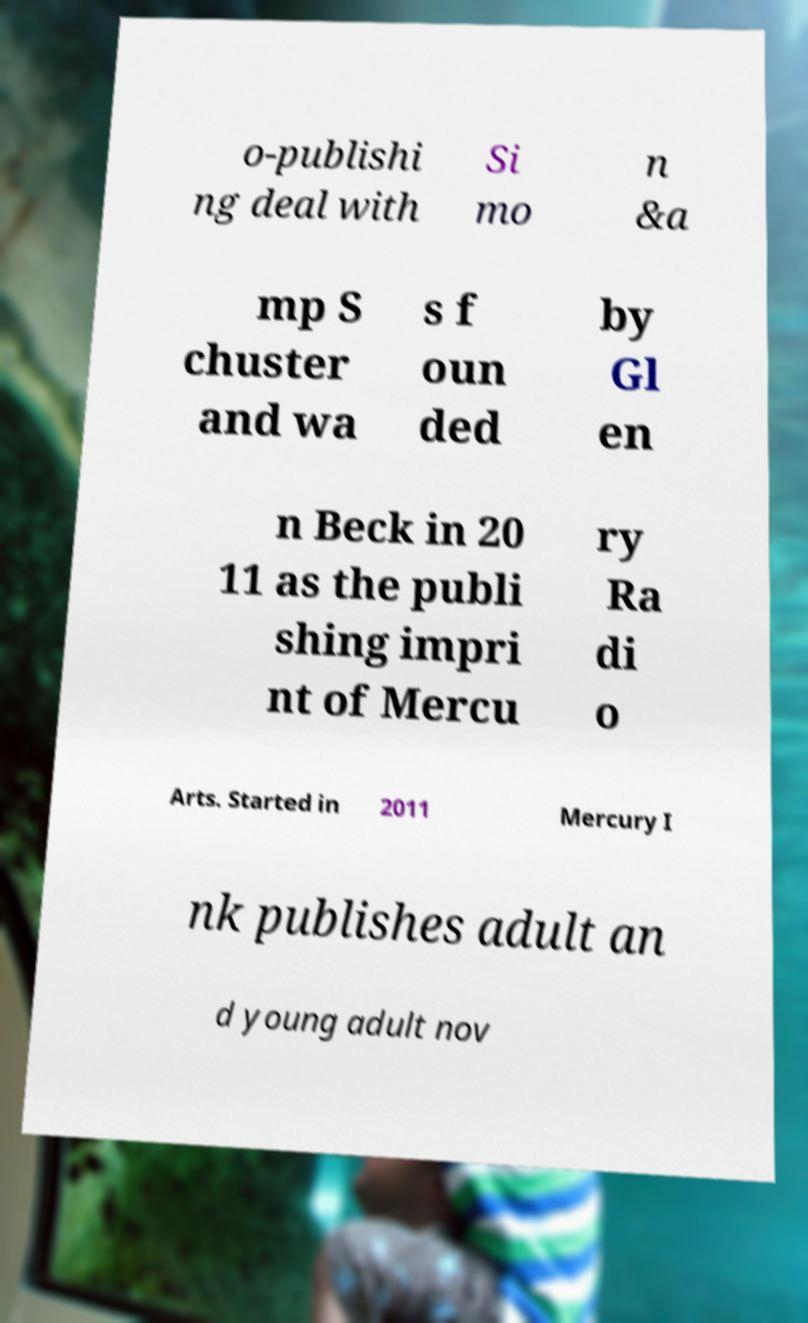Please identify and transcribe the text found in this image. o-publishi ng deal with Si mo n &a mp S chuster and wa s f oun ded by Gl en n Beck in 20 11 as the publi shing impri nt of Mercu ry Ra di o Arts. Started in 2011 Mercury I nk publishes adult an d young adult nov 